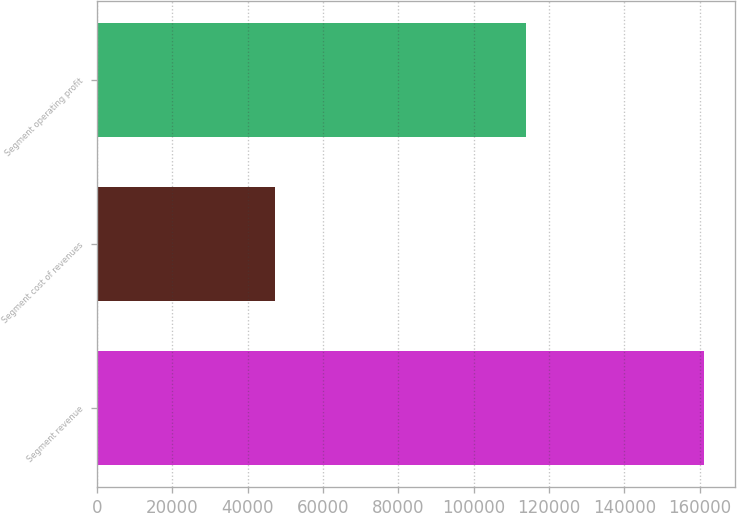<chart> <loc_0><loc_0><loc_500><loc_500><bar_chart><fcel>Segment revenue<fcel>Segment cost of revenues<fcel>Segment operating profit<nl><fcel>161277<fcel>47259<fcel>114018<nl></chart> 